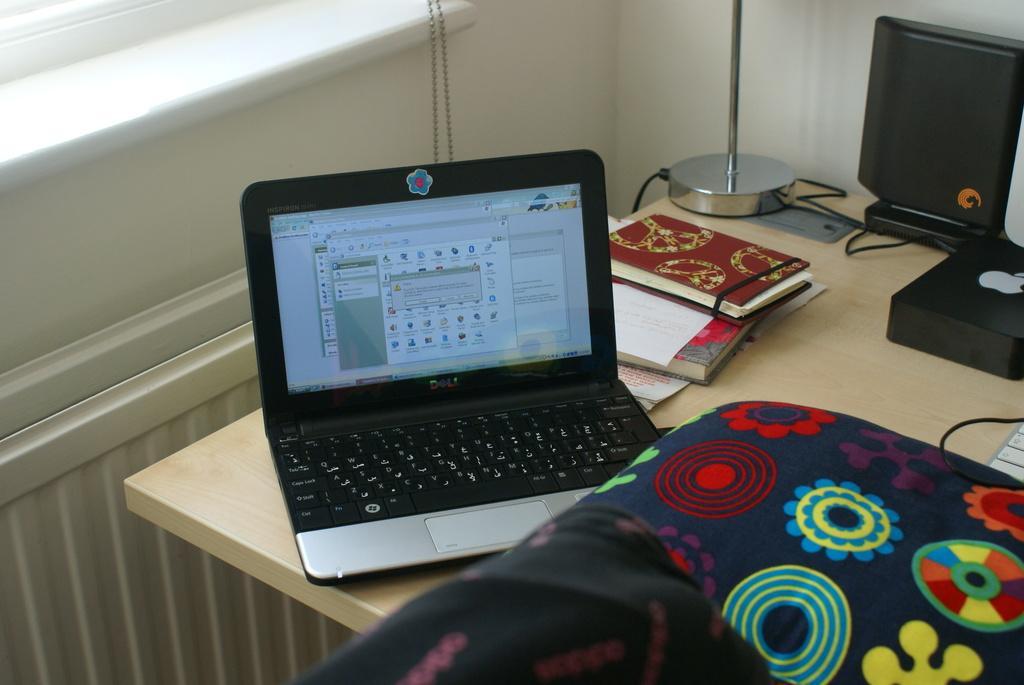Please provide a concise description of this image. In the image I can see a table on which there is a screen, book and some other things around. 